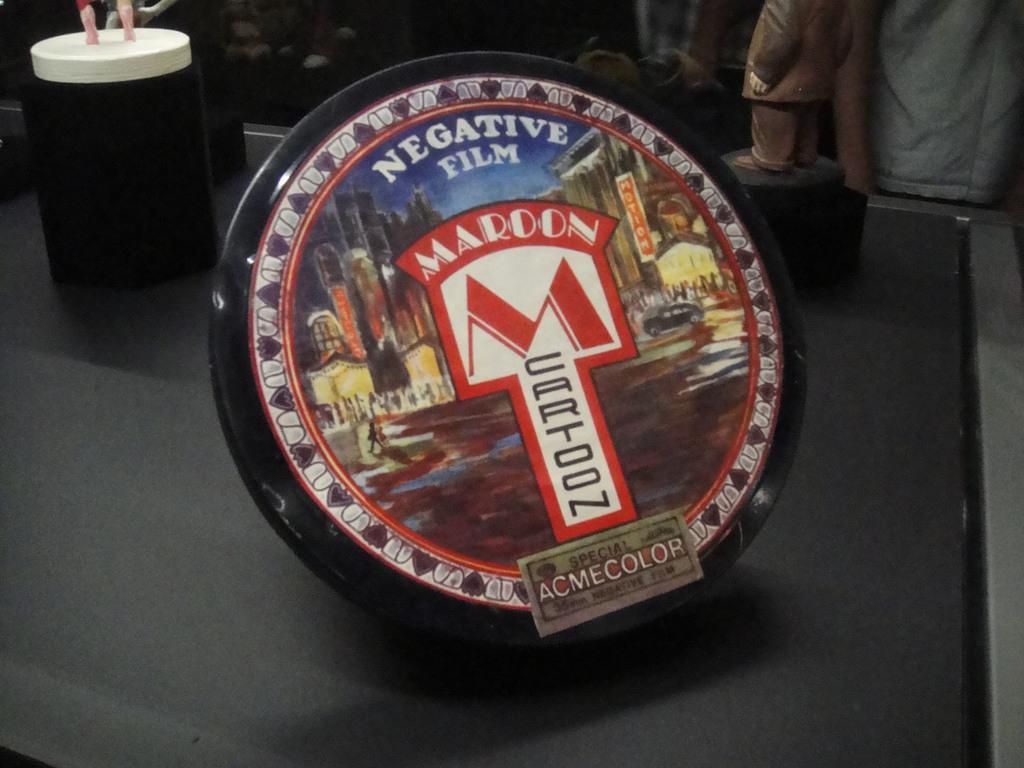Please provide a concise description of this image. In the image there is a glass,statue and a tray on a table, behind it the background is blurry and dark. 